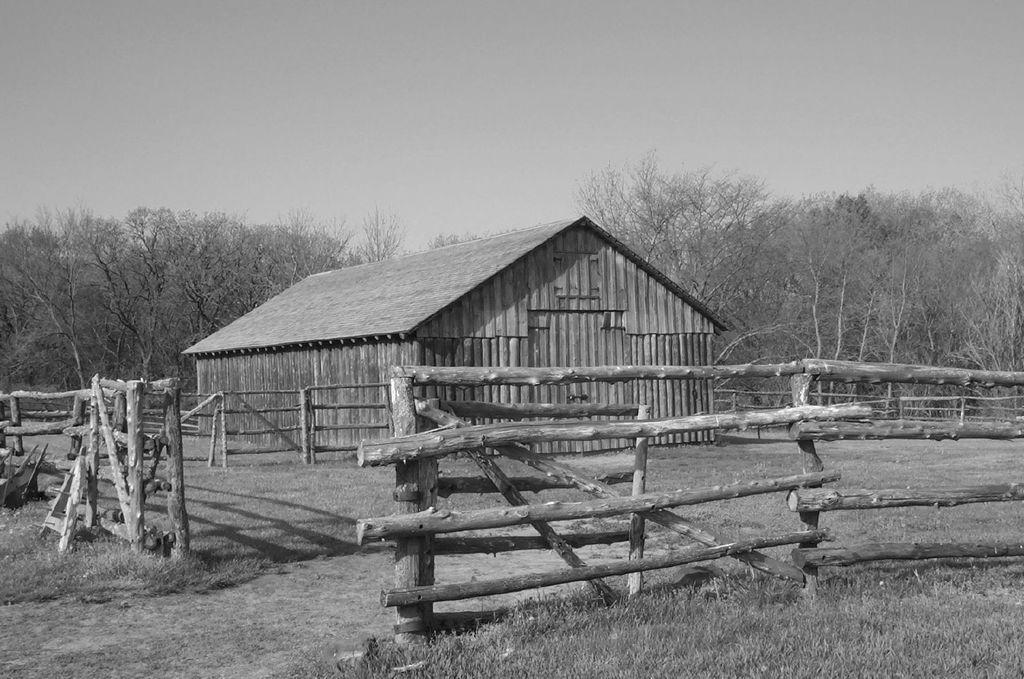Could you give a brief overview of what you see in this image? This is a black and white image. In the image we can see wooden house surrounded by a wooden fence, grass, ground, trees and sky. 